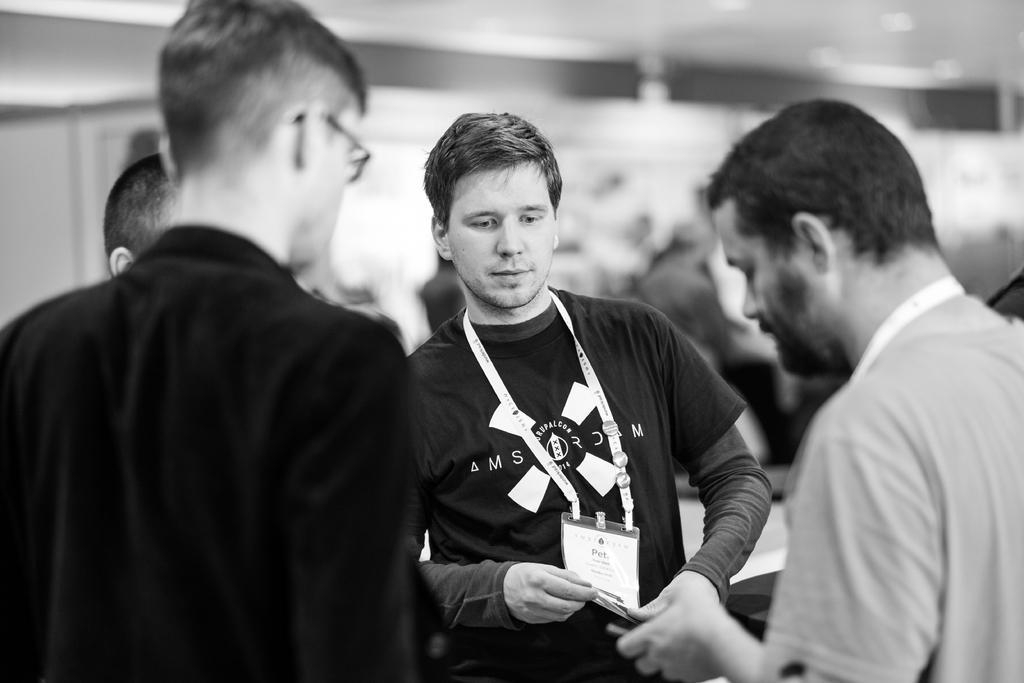How would you summarize this image in a sentence or two? In this image we can see some people standing. We can also see a person holding his id card. On the right side we can see a person holding something in his hand. 